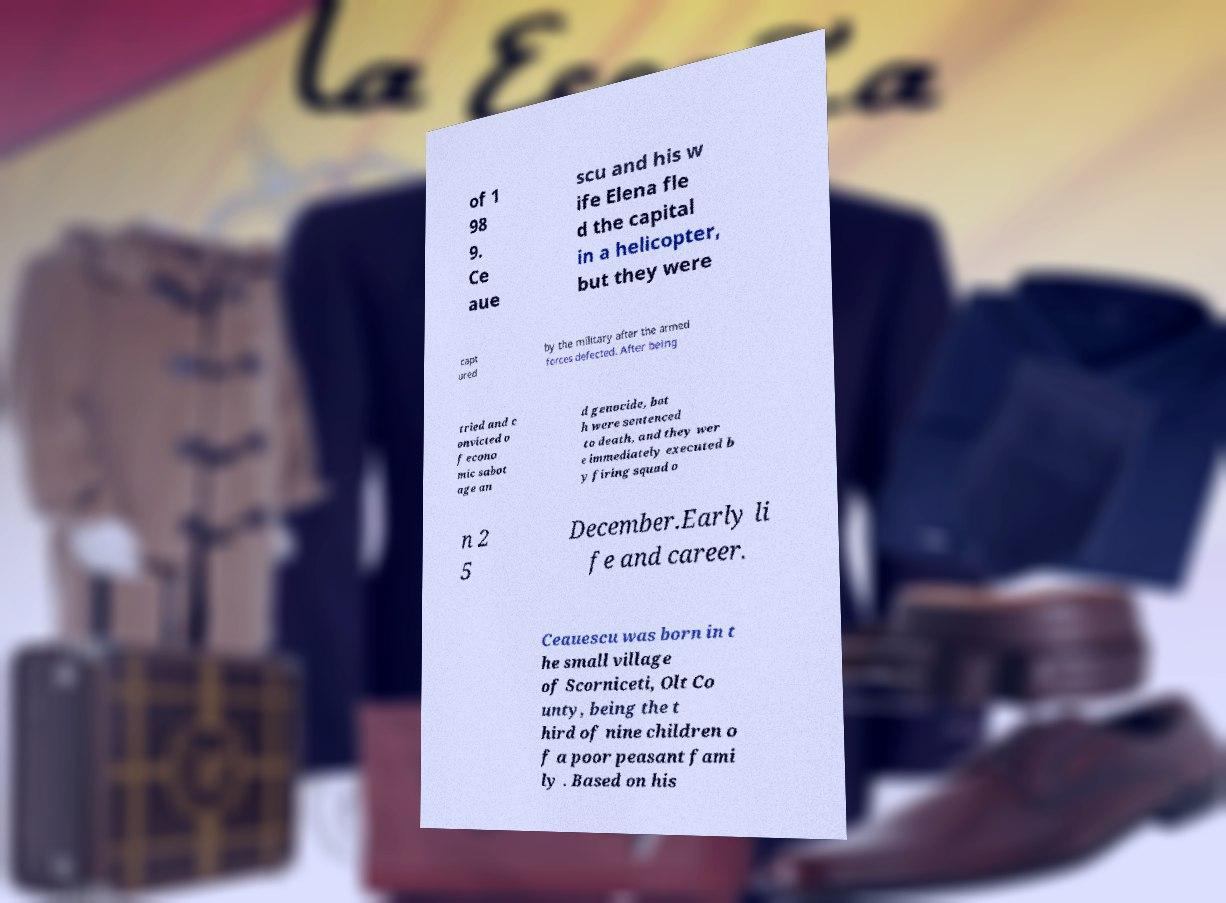Could you extract and type out the text from this image? of 1 98 9. Ce aue scu and his w ife Elena fle d the capital in a helicopter, but they were capt ured by the military after the armed forces defected. After being tried and c onvicted o f econo mic sabot age an d genocide, bot h were sentenced to death, and they wer e immediately executed b y firing squad o n 2 5 December.Early li fe and career. Ceauescu was born in t he small village of Scorniceti, Olt Co unty, being the t hird of nine children o f a poor peasant fami ly . Based on his 